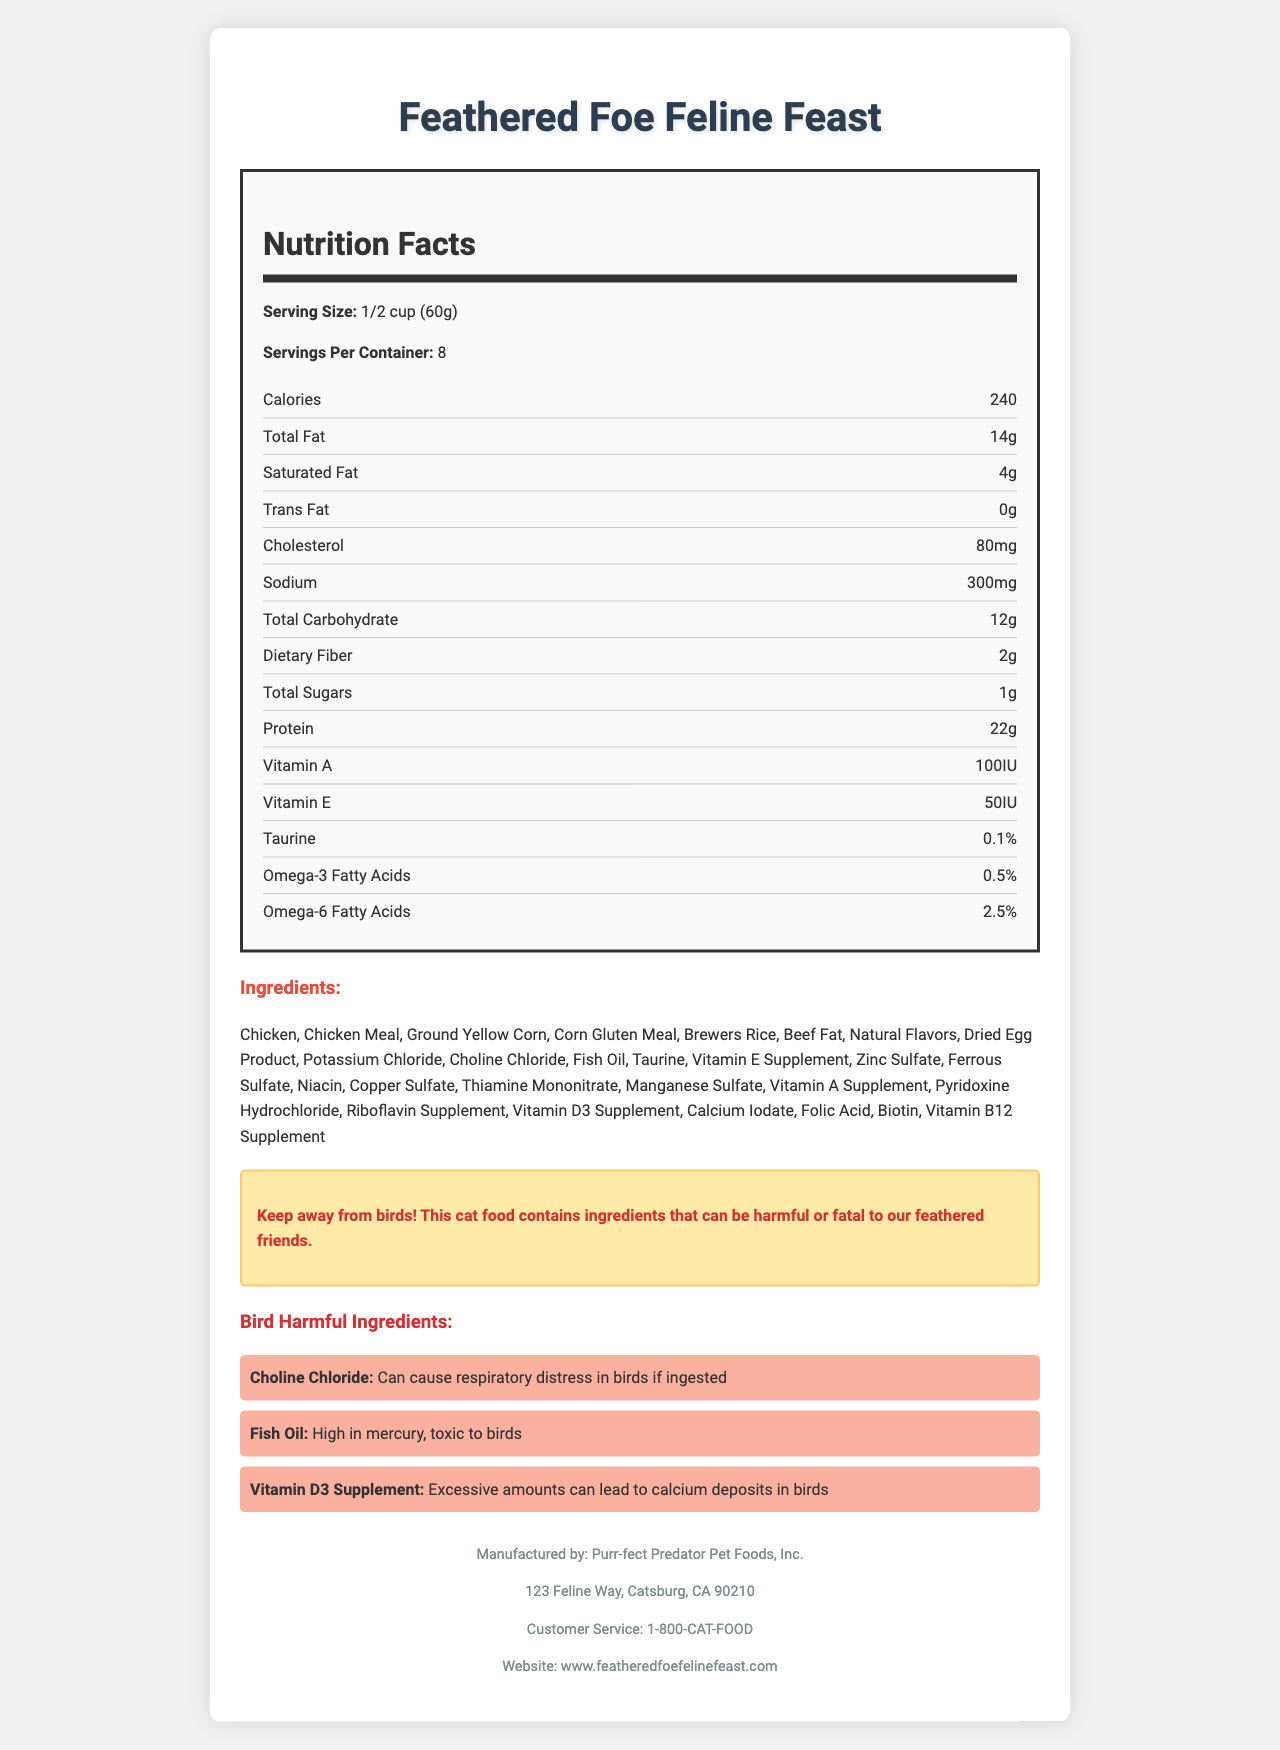what is the product name? The product name is clearly stated at the beginning of the document.
Answer: Feathered Foe Feline Feast what is the serving size? The serving size is listed near the top, under the nutrition facts section.
Answer: 1/2 cup (60g) how many servings are in the container? The number of servings per container can be found in the nutrition facts section.
Answer: 8 what are the total calories per serving? The calorie count per serving is listed within the nutrition facts section.
Answer: 240 calories which ingredients are harmful to birds? These ingredients are specifically listed under the "Bird Harmful Ingredients" section with detailed reasons for their harmful effects.
Answer: Choline Chloride, Fish Oil, Vitamin D3 Supplement how much protein is in one serving? The protein content per serving is provided in the nutrition facts section.
Answer: 22g List two vitamins included in the cat food. Vitamin A and Vitamin E are mentioned in the nutrition facts section.
Answer: Vitamin A, Vitamin E which of these ingredients causes respiratory distress in birds? A. Fish Oil B. Choline Chloride C. Vitamin E D. Natural Flavors The document states that Choline Chloride can cause respiratory distress in birds if ingested.
Answer: B. Choline Chloride how much sodium is in each serving? A. 300mg B. 200mg C. 100mg D. 400mg The sodium content is specifically listed in the nutrition facts section as 300mg per serving.
Answer: A. 300mg can this cat food be harmful to birds? There is a warning explicitly mentioning that the cat food contains ingredients harmful or fatal to birds.
Answer: Yes what is the main idea of the document? The document includes nutritional facts, ingredients, a warning about bird harmful ingredients, manufacturer details, and customer service information.
Answer: The document provides detailed nutritional information about Feathered Foe Feline Feast cat food and highlights the presence of ingredients that are harmful to birds. what is the address of the manufacturer? The manufacturer address is provided in the footer section of the document.
Answer: 123 Feline Way, Catsburg, CA 90210 how many grams are in one serving? The serving size is listed as 1/2 cup (60g) in the nutrition facts section.
Answer: 60g how much dietary fiber is in one serving? The dietary fiber content is listed in the nutrition facts section.
Answer: 2g which ingredient is high in mercury and toxic to birds? The document states that Fish Oil is high in mercury and toxic to birds under the "Bird Harmful Ingredients" section.
Answer: Fish Oil what website can customers visit for more information? The website is provided in the footer section of the document.
Answer: www.featheredfoefelinefeast.com is the vitamin B12 supplement harmful to birds? The document does not list Vitamin B12 as harmful to birds; the harmful ingredients are Choline Chloride, Fish Oil, and Vitamin D3 Supplement.
Answer: No what is the total carbohydrate content in one serving? The total carbohydrate content is listed within the nutrition facts section.
Answer: 12g can i find the expiration date of the product in the document? The document does not include information related to the expiration date of the product.
Answer: Not enough information 